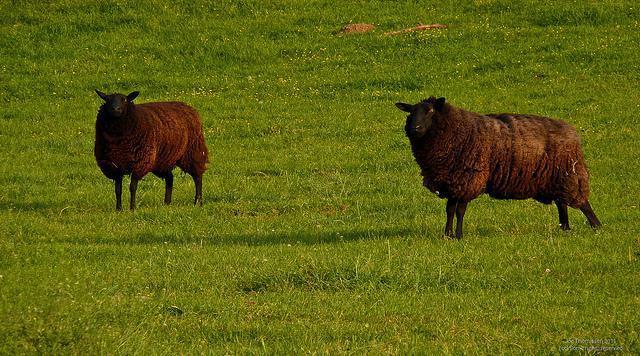How many animals can be seen?
Give a very brief answer. 2. How many sheep are in the photo?
Give a very brief answer. 2. 